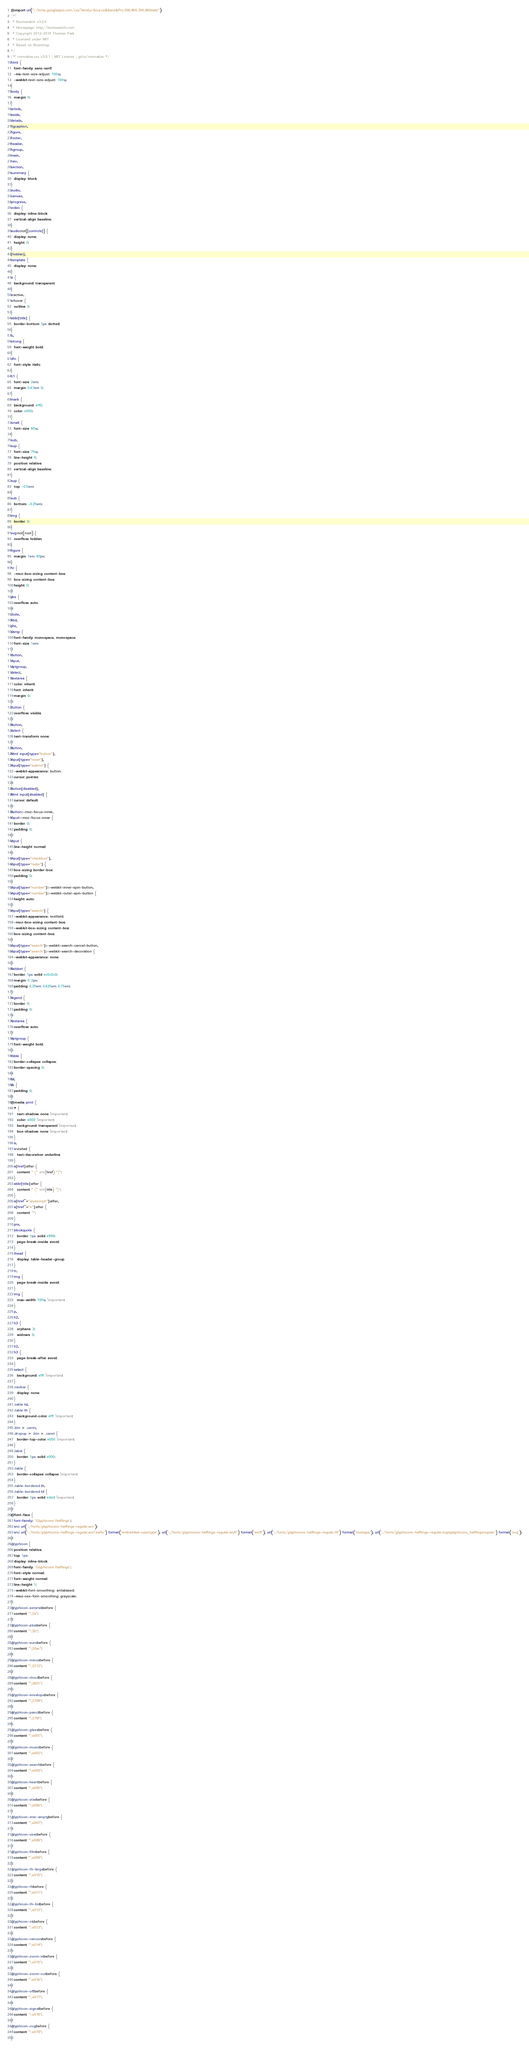Convert code to text. <code><loc_0><loc_0><loc_500><loc_500><_CSS_>@import url("//fonts.googleapis.com/css?family=Source&Sans&Pro:300,400,700,400italic");
/*!
 * Bootswatch v3.2.0
 * Homepage: http://bootswatch.com
 * Copyright 2012-2014 Thomas Park
 * Licensed under MIT
 * Based on Bootstrap
*/
/*! normalize.css v3.0.1 | MIT License | git.io/normalize */
html {
  font-family: sans-serif;
  -ms-text-size-adjust: 100%;
  -webkit-text-size-adjust: 100%;
}
body {
  margin: 0;
}
article,
aside,
details,
figcaption,
figure,
footer,
header,
hgroup,
main,
nav,
section,
summary {
  display: block;
}
audio,
canvas,
progress,
video {
  display: inline-block;
  vertical-align: baseline;
}
audio:not([controls]) {
  display: none;
  height: 0;
}
[hidden],
template {
  display: none;
}
a {
  background: transparent;
}
a:active,
a:hover {
  outline: 0;
}
abbr[title] {
  border-bottom: 1px dotted;
}
b,
strong {
  font-weight: bold;
}
dfn {
  font-style: italic;
}
h1 {
  font-size: 2em;
  margin: 0.67em 0;
}
mark {
  background: #ff0;
  color: #000;
}
small {
  font-size: 80%;
}
sub,
sup {
  font-size: 75%;
  line-height: 0;
  position: relative;
  vertical-align: baseline;
}
sup {
  top: -0.5em;
}
sub {
  bottom: -0.25em;
}
img {
  border: 0;
}
svg:not(:root) {
  overflow: hidden;
}
figure {
  margin: 1em 40px;
}
hr {
  -moz-box-sizing: content-box;
  box-sizing: content-box;
  height: 0;
}
pre {
  overflow: auto;
}
code,
kbd,
pre,
samp {
  font-family: monospace, monospace;
  font-size: 1em;
}
button,
input,
optgroup,
select,
textarea {
  color: inherit;
  font: inherit;
  margin: 0;
}
button {
  overflow: visible;
}
button,
select {
  text-transform: none;
}
button,
html input[type="button"],
input[type="reset"],
input[type="submit"] {
  -webkit-appearance: button;
  cursor: pointer;
}
button[disabled],
html input[disabled] {
  cursor: default;
}
button::-moz-focus-inner,
input::-moz-focus-inner {
  border: 0;
  padding: 0;
}
input {
  line-height: normal;
}
input[type="checkbox"],
input[type="radio"] {
  box-sizing: border-box;
  padding: 0;
}
input[type="number"]::-webkit-inner-spin-button,
input[type="number"]::-webkit-outer-spin-button {
  height: auto;
}
input[type="search"] {
  -webkit-appearance: textfield;
  -moz-box-sizing: content-box;
  -webkit-box-sizing: content-box;
  box-sizing: content-box;
}
input[type="search"]::-webkit-search-cancel-button,
input[type="search"]::-webkit-search-decoration {
  -webkit-appearance: none;
}
fieldset {
  border: 1px solid #c0c0c0;
  margin: 0 2px;
  padding: 0.35em 0.625em 0.75em;
}
legend {
  border: 0;
  padding: 0;
}
textarea {
  overflow: auto;
}
optgroup {
  font-weight: bold;
}
table {
  border-collapse: collapse;
  border-spacing: 0;
}
td,
th {
  padding: 0;
}
@media print {
  * {
    text-shadow: none !important;
    color: #000 !important;
    background: transparent !important;
    box-shadow: none !important;
  }
  a,
  a:visited {
    text-decoration: underline;
  }
  a[href]:after {
    content: " (" attr(href) ")";
  }
  abbr[title]:after {
    content: " (" attr(title) ")";
  }
  a[href^="javascript:"]:after,
  a[href^="#"]:after {
    content: "";
  }
  pre,
  blockquote {
    border: 1px solid #999;
    page-break-inside: avoid;
  }
  thead {
    display: table-header-group;
  }
  tr,
  img {
    page-break-inside: avoid;
  }
  img {
    max-width: 100% !important;
  }
  p,
  h2,
  h3 {
    orphans: 3;
    widows: 3;
  }
  h2,
  h3 {
    page-break-after: avoid;
  }
  select {
    background: #fff !important;
  }
  .navbar {
    display: none;
  }
  .table td,
  .table th {
    background-color: #fff !important;
  }
  .btn > .caret,
  .dropup > .btn > .caret {
    border-top-color: #000 !important;
  }
  .label {
    border: 1px solid #000;
  }
  .table {
    border-collapse: collapse !important;
  }
  .table-bordered th,
  .table-bordered td {
    border: 1px solid #ddd !important;
  }
}
@font-face {
  font-family: 'Glyphicons Halflings';
  src: url('../fonts/glyphicons-halflings-regular.eot');
  src: url('../fonts/glyphicons-halflings-regular.eot?#iefix') format('embedded-opentype'), url('../fonts/glyphicons-halflings-regular.woff') format('woff'), url('../fonts/glyphicons-halflings-regular.ttf') format('truetype'), url('../fonts/glyphicons-halflings-regular.svg#glyphicons_halflingsregular') format('svg');
}
.glyphicon {
  position: relative;
  top: 1px;
  display: inline-block;
  font-family: 'Glyphicons Halflings';
  font-style: normal;
  font-weight: normal;
  line-height: 1;
  -webkit-font-smoothing: antialiased;
  -moz-osx-font-smoothing: grayscale;
}
.glyphicon-asterisk:before {
  content: "\2a";
}
.glyphicon-plus:before {
  content: "\2b";
}
.glyphicon-euro:before {
  content: "\20ac";
}
.glyphicon-minus:before {
  content: "\2212";
}
.glyphicon-cloud:before {
  content: "\2601";
}
.glyphicon-envelope:before {
  content: "\2709";
}
.glyphicon-pencil:before {
  content: "\270f";
}
.glyphicon-glass:before {
  content: "\e001";
}
.glyphicon-music:before {
  content: "\e002";
}
.glyphicon-search:before {
  content: "\e003";
}
.glyphicon-heart:before {
  content: "\e005";
}
.glyphicon-star:before {
  content: "\e006";
}
.glyphicon-star-empty:before {
  content: "\e007";
}
.glyphicon-user:before {
  content: "\e008";
}
.glyphicon-film:before {
  content: "\e009";
}
.glyphicon-th-large:before {
  content: "\e010";
}
.glyphicon-th:before {
  content: "\e011";
}
.glyphicon-th-list:before {
  content: "\e012";
}
.glyphicon-ok:before {
  content: "\e013";
}
.glyphicon-remove:before {
  content: "\e014";
}
.glyphicon-zoom-in:before {
  content: "\e015";
}
.glyphicon-zoom-out:before {
  content: "\e016";
}
.glyphicon-off:before {
  content: "\e017";
}
.glyphicon-signal:before {
  content: "\e018";
}
.glyphicon-cog:before {
  content: "\e019";
}</code> 